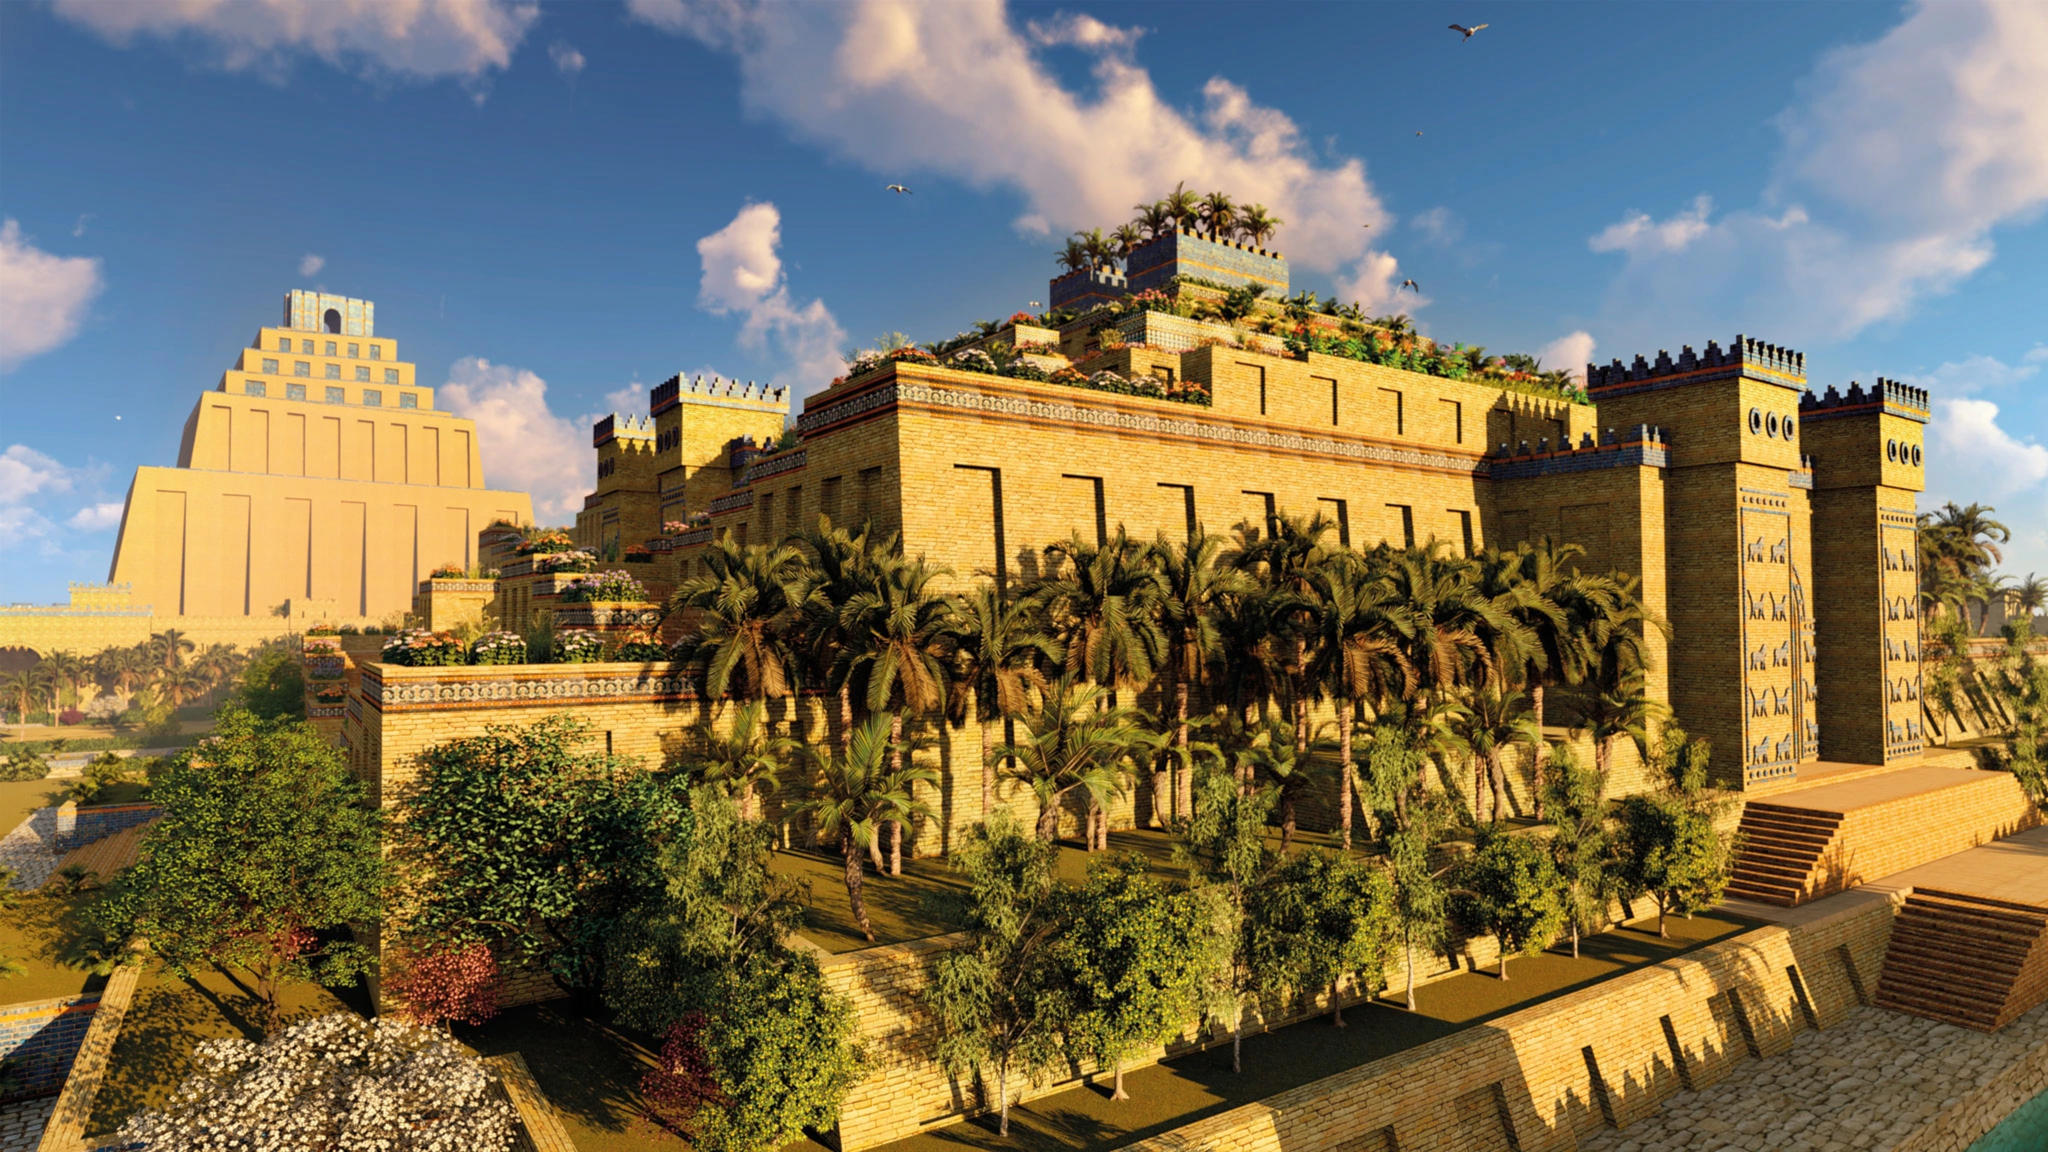Can you describe the architectural significance of the structures in this image? The architectural significance of the structures in the image of Babylon is profound. The city walls are crafted from brick and adorned with detailed reliefs, showcasing the artistry and cultural richness of Babylon. The stepped towers are reminiscent of ziggurats, illustrating the city’s religious and ceremonial practices. The crenellations add a militaristic element, suggesting the city’s need for defense and the might of its empire. Together, these elements reflect a blend of aesthetic beauty, religious significance, and practical defense, encapsulating the grandeur of Babylonian civilization. What role did such gardens play in the daily lives of the Babylonians? The gardens in Babylon, famously represented by the Hanging Gardens, played multiple roles in the daily lives of the Babylonians. Primarily, they were a symbol of wealth and prosperity, showcasing the city’s ability to cultivate lush greenery amidst an arid landscape. These gardens were places of leisure and relaxation for the elite, offering a respite from the city's bustling life. They also had a religious significance, as some were dedicated to deities, serving as venues for various rituals and ceremonies. Moreover, they demonstrated advanced irrigation techniques, highlighting the ingenuity and engineering skills of Babylonian society. 